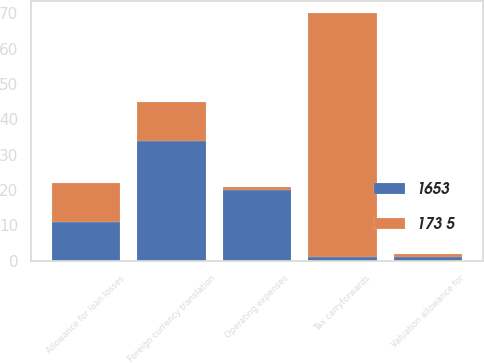<chart> <loc_0><loc_0><loc_500><loc_500><stacked_bar_chart><ecel><fcel>Foreign currency translation<fcel>Operating expenses<fcel>Allowance for loan losses<fcel>Tax carryforwards<fcel>Valuation allowance for<nl><fcel>1653<fcel>34<fcel>20<fcel>11<fcel>1<fcel>1<nl><fcel>173 5<fcel>11<fcel>1<fcel>11<fcel>69<fcel>1<nl></chart> 